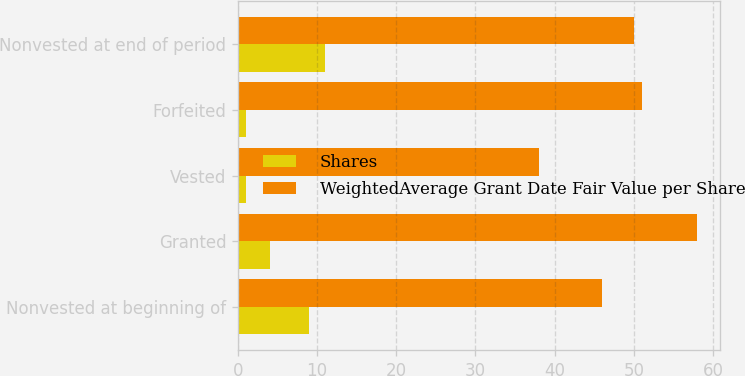<chart> <loc_0><loc_0><loc_500><loc_500><stacked_bar_chart><ecel><fcel>Nonvested at beginning of<fcel>Granted<fcel>Vested<fcel>Forfeited<fcel>Nonvested at end of period<nl><fcel>Shares<fcel>9<fcel>4<fcel>1<fcel>1<fcel>11<nl><fcel>WeightedAverage Grant Date Fair Value per Share<fcel>46<fcel>58<fcel>38<fcel>51<fcel>50<nl></chart> 